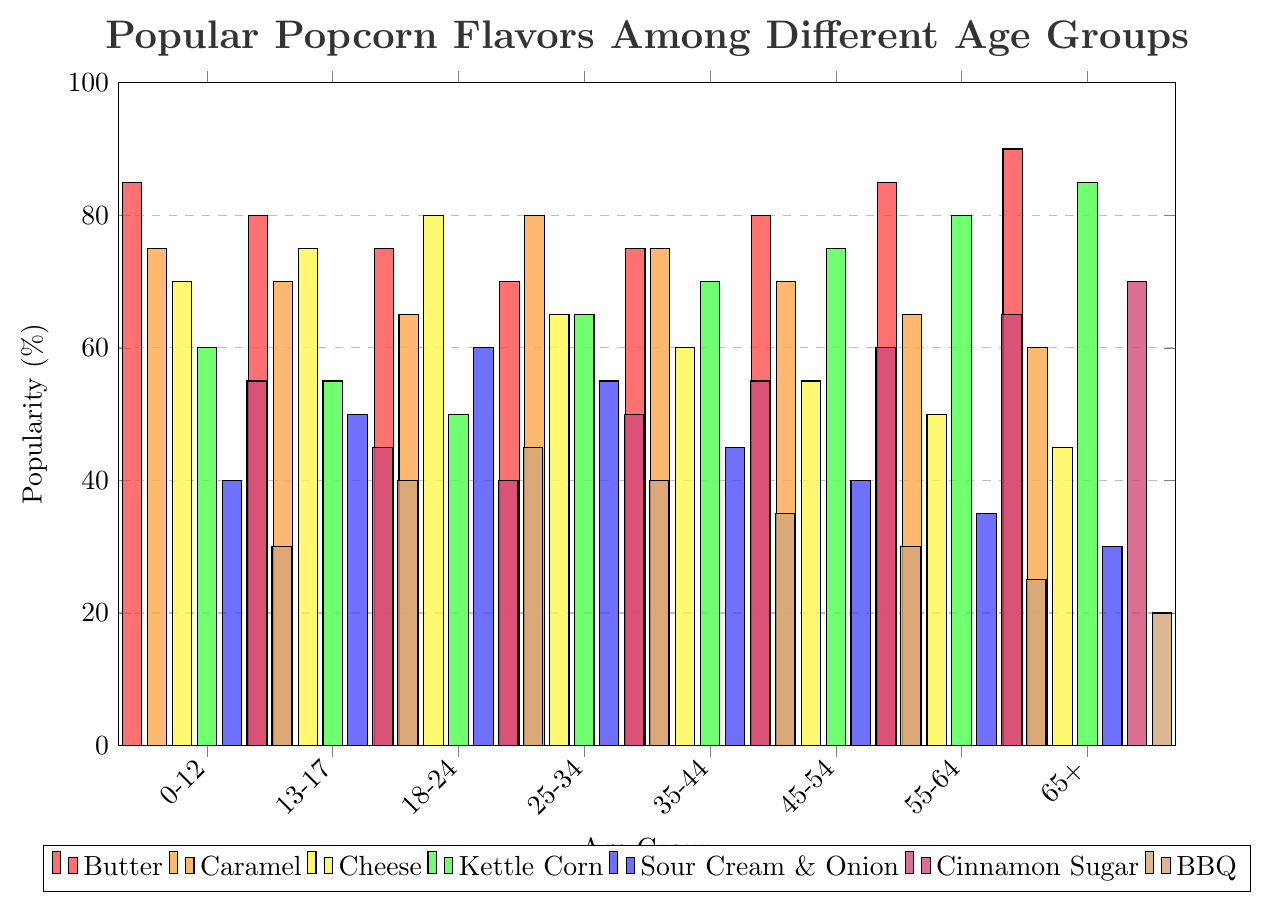What is the most popular popcorn flavor among the age group 0-12? The bar representing Butter for the age group 0-12 is the highest, reaching a popularity of 85%.
Answer: Butter Which popcorn flavor is preferred by the age group 65+ more than any other age group? The bar for Cinnamon Sugar in the age group 65+ is higher than in any other age group, reaching 70%.
Answer: Cinnamon Sugar How does the popularity of Cheese popcorn vary between the age groups 13-17 and 18-24? The bar for Cheese in age group 13-17 reaches 75%, while in age group 18-24, it reaches 80%. This shows an increase in popularity.
Answer: Increases What is the difference in popularity between Kettle Corn and BBQ among the age group 25-34? The popularity of Kettle Corn in the age group 25-34 is 65%, whereas BBQ is 40%. The difference is 65% - 40% = 25%.
Answer: 25% Which age group has the least preference for BBQ popcorn? The bar for BBQ is the lowest for the age group 65+, reaching only 20%.
Answer: 65+ What is the average popularity of Butter popcorn across all age groups? The popularity values for Butter across all age groups are 85, 80, 75, 70, 75, 80, 85, and 90. Summing these values gives 640, and there are 8 age groups, so the average is 640 / 8 = 80%.
Answer: 80% Which flavor shows a continuous decrease in popularity as the age increases? The Sour Cream & Onion flavor's popularity decreases continuously from 40% in the 0-12 age group to 30% in the 65+ age group.
Answer: Sour Cream & Onion Which flavor is equally popular among the age groups 18-24 and 25-34? The popularity of Cheese for both age groups 18-24 and 25-34 is 80%.
Answer: Cheese Compare the popularity of Caramel popcorn between the youngest (0-12) and the oldest (65+) age groups. Caramel popcorn has a popularity of 75% in 0-12 and 60% in 65+.
Answer: Younger group prefers it more 